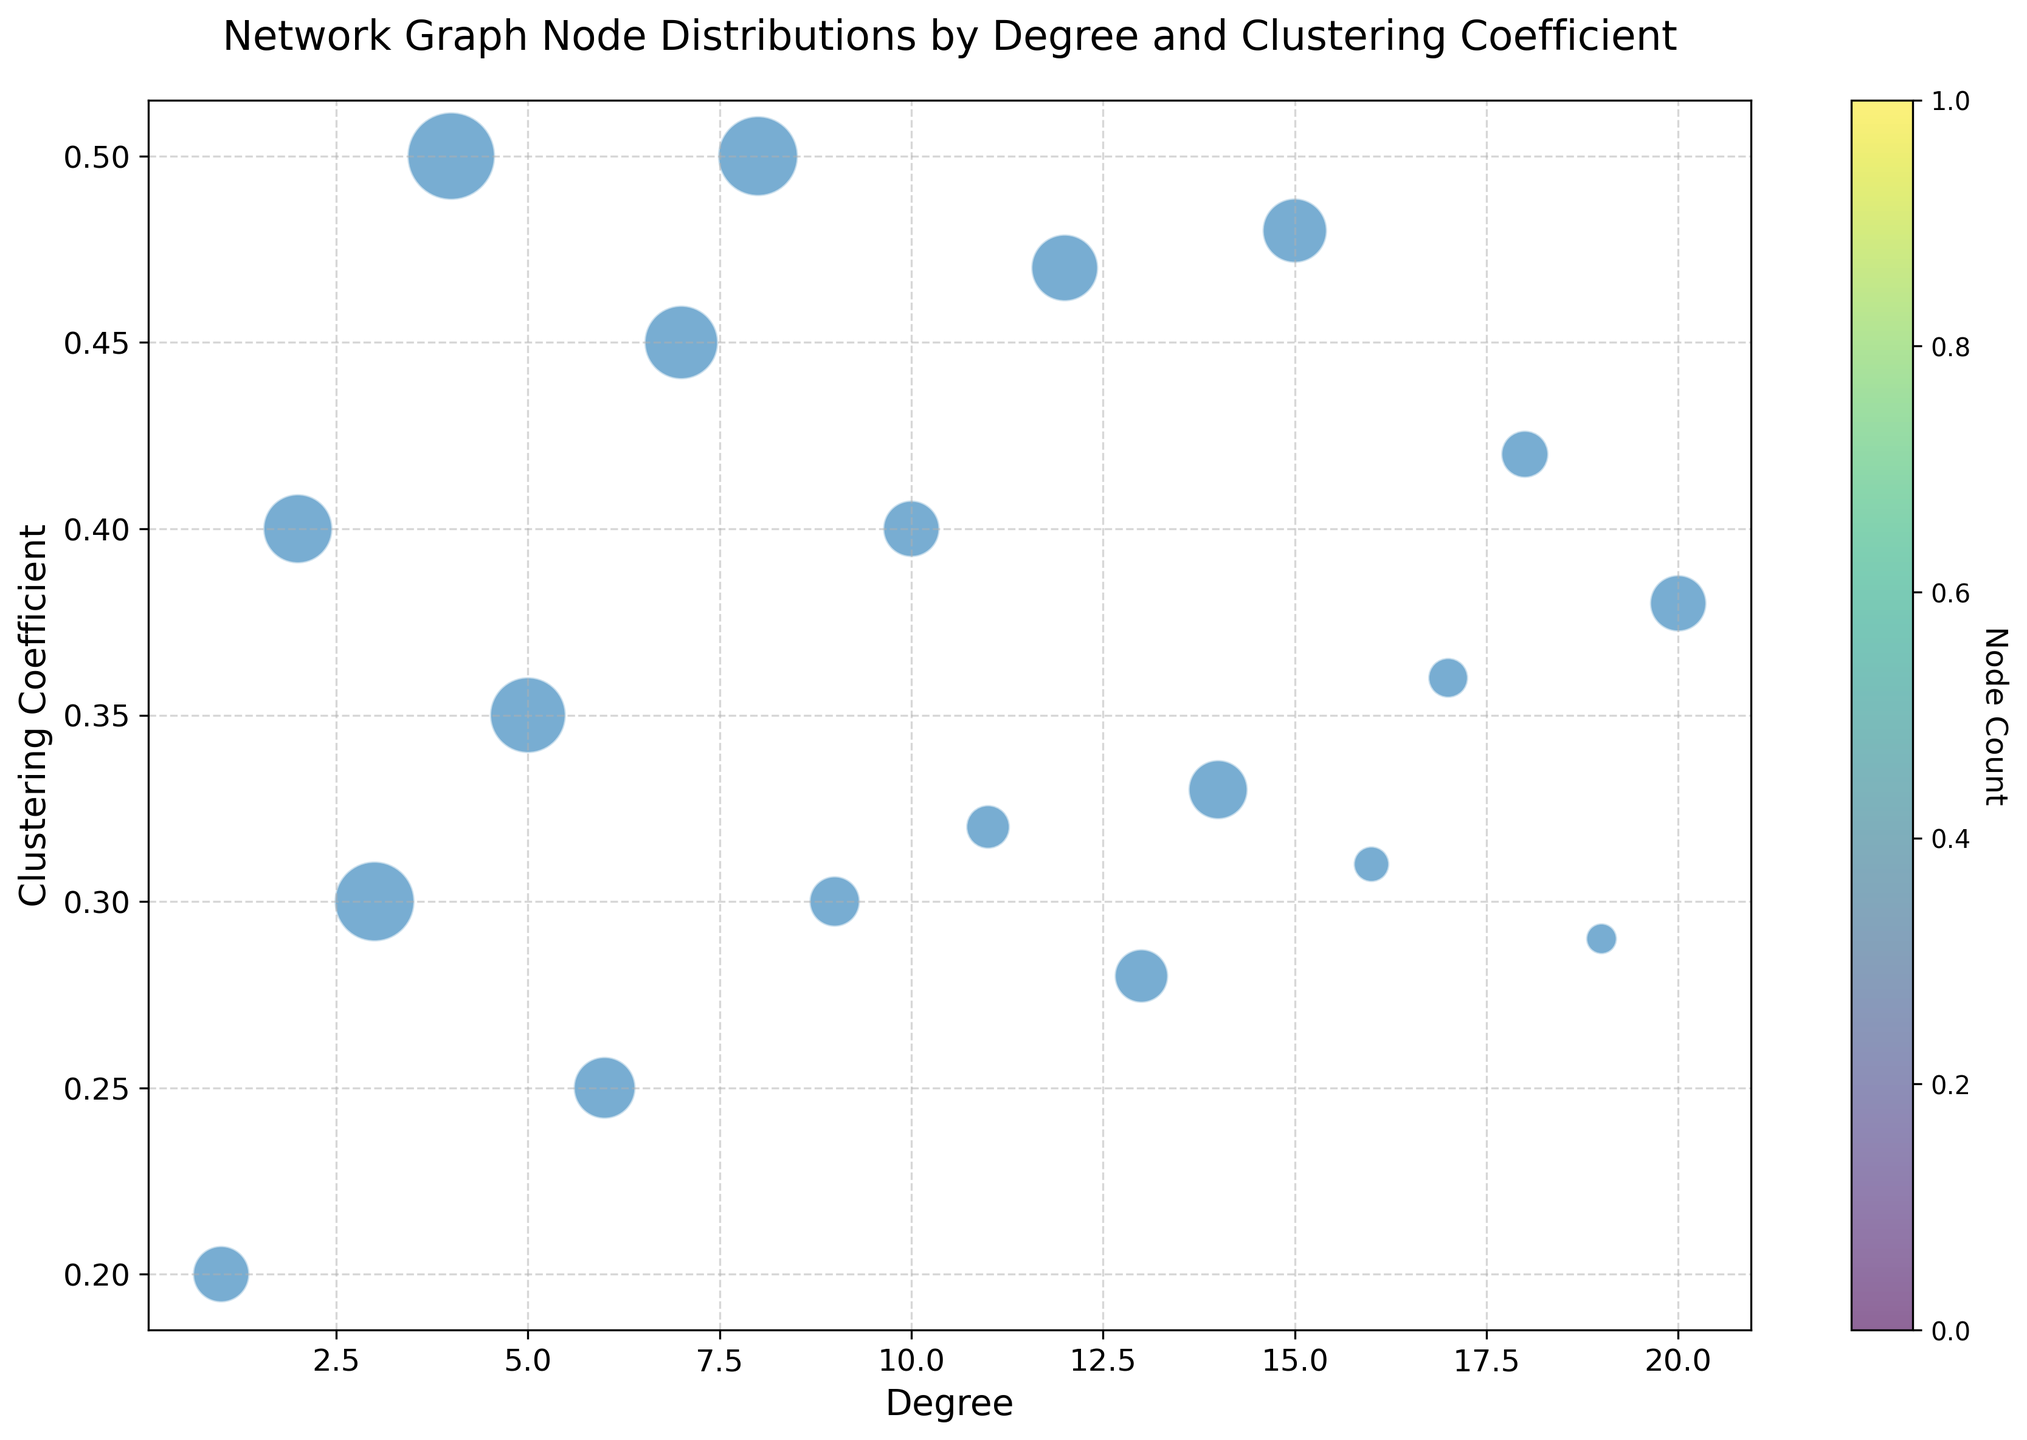What is the highest degree recorded in the network graph? The x-axis represents the degree, and the highest point on the x-axis corresponds to the highest degree. By inspecting the x-axis, the highest degree recorded is 20.
Answer: 20 Which degree nodes have the maximum clustering coefficient? The y-axis represents the clustering coefficient. To find the maximum, observe the highest point on the y-axis. The maximum clustering coefficient is 0.5, corresponding to nodes with degrees of 4 and 8.
Answer: 4, 8 For degree 10 nodes, what is the clustering coefficient? Locate the point where the x-axis equals 10. The y-coordinate of this point represents the clustering coefficient.
Answer: 0.4 What node degree has the largest representation by count? Each point size corresponds to the count. The largest size indicates the largest count. Degree 4 has the largest bubble size.
Answer: 4 I see that the degree 20 nodes have a clustering coefficient of 0.38. What is the count for these nodes? Locate the point where the x-axis equals 20 and the y-axis equals 0.38. The size of this bubble represents the count, which, when referred to the color bar and bubble size, is 50.
Answer: 50 